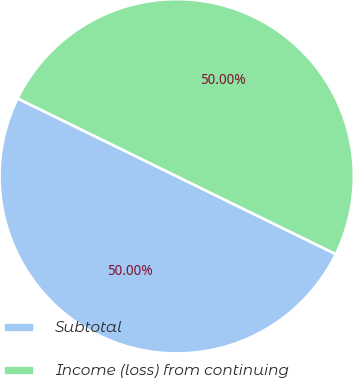<chart> <loc_0><loc_0><loc_500><loc_500><pie_chart><fcel>Subtotal<fcel>Income (loss) from continuing<nl><fcel>50.0%<fcel>50.0%<nl></chart> 